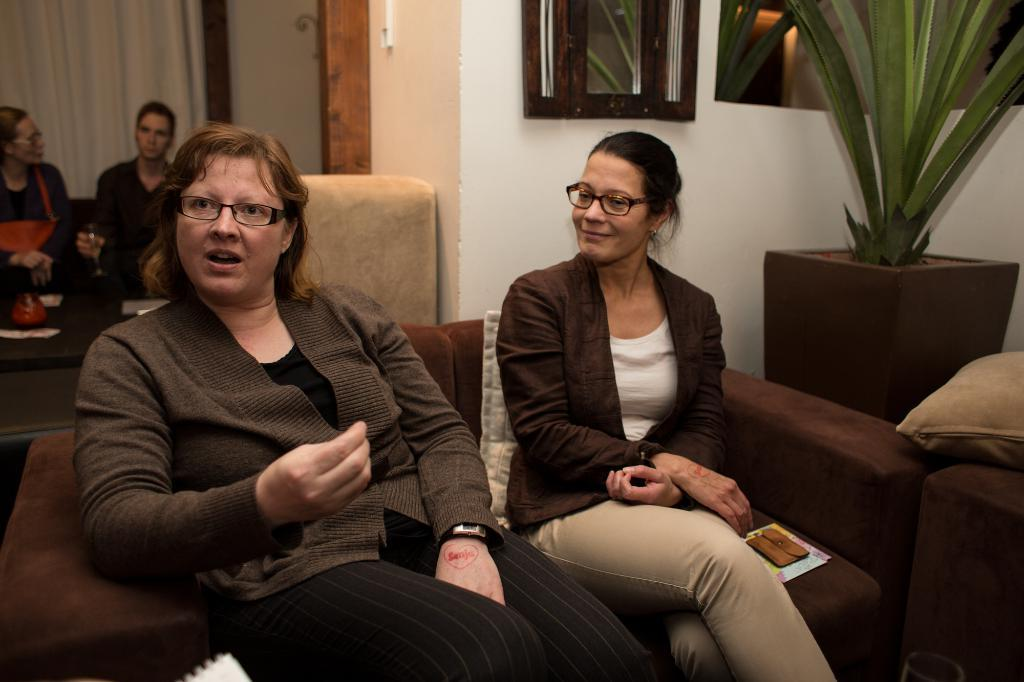How many people are sitting on the sofa in the image? There are four persons sitting on the sofa in the image. What can be seen in addition to the people on the sofa? There is a pillow in the image. Are there any other objects or elements in the room? Yes, there is a plant, a curtain, and a wall in the image. What type of honey can be seen dripping from the curtain in the image? There is no honey present in the image; it only features a curtain, a wall, a plant, and a sofa with four persons sitting on it. 